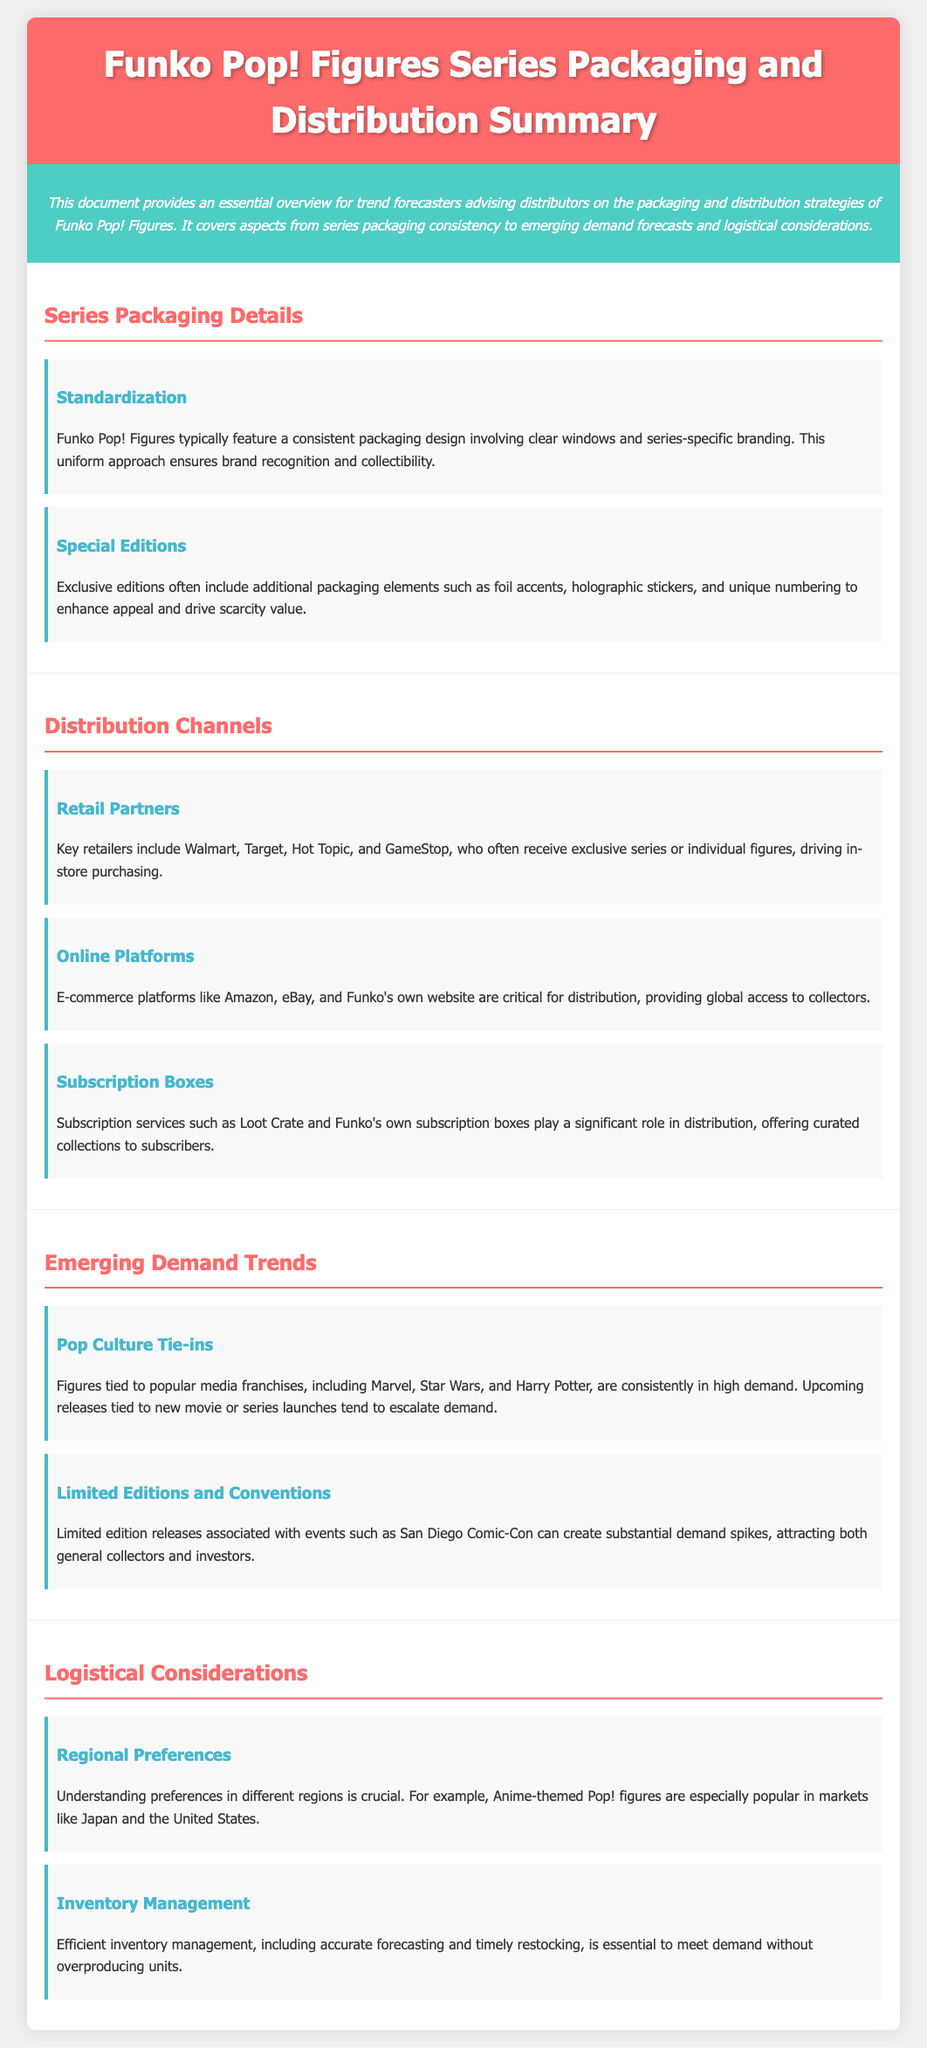What are the key retailers mentioned? The document lists Walmart, Target, Hot Topic, and GameStop as key retailers in the distribution of Funko Pop! Figures.
Answer: Walmart, Target, Hot Topic, and GameStop What enhances the appeal of special editions? Special editions often include additional packaging elements such as foil accents, holographic stickers, and unique numbering, which enhance their appeal.
Answer: Foil accents, holographic stickers, and unique numbering Which franchises are tied to high demand? The document specifies that figures tied to popular media franchises like Marvel, Star Wars, and Harry Potter are consistently in high demand.
Answer: Marvel, Star Wars, and Harry Potter What type of subscription services are mentioned? Subscription services such as Loot Crate and Funko's own subscription boxes are mentioned as critical for distribution.
Answer: Loot Crate and Funko's subscription boxes What is crucial for inventory management? Efficient inventory management relies on accurate forecasting and timely restocking to meet demand without overproducing units.
Answer: Accurate forecasting and timely restocking What is a significant driver for demand spikes? Limited edition releases associated with events such as San Diego Comic-Con can create substantial demand spikes.
Answer: San Diego Comic-Con How does regional preference affect collectible popularity? Understanding regional preferences is essential, as Anime-themed Pop! figures are particularly popular in Japan and the U.S.
Answer: Japan and the U.S What does series packaging typically involve? Funko Pop! Figures feature consistent packaging design involving clear windows and series-specific branding.
Answer: Clear windows and series-specific branding What is a hallmark of exclusive editions? Exclusive editions often feature additional elements such as foil accents to enhance their collectibility.
Answer: Foil accents 